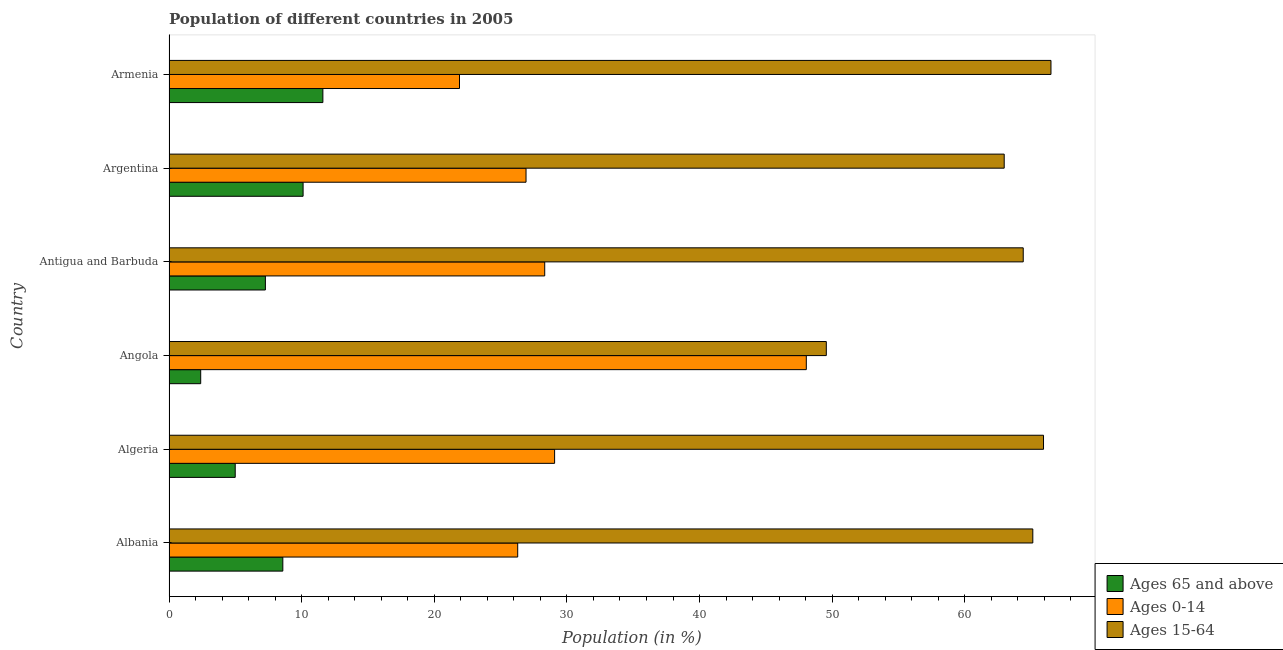How many different coloured bars are there?
Your answer should be compact. 3. How many bars are there on the 3rd tick from the top?
Ensure brevity in your answer.  3. How many bars are there on the 3rd tick from the bottom?
Offer a terse response. 3. In how many cases, is the number of bars for a given country not equal to the number of legend labels?
Provide a succinct answer. 0. What is the percentage of population within the age-group 0-14 in Armenia?
Your answer should be very brief. 21.9. Across all countries, what is the maximum percentage of population within the age-group of 65 and above?
Keep it short and to the point. 11.6. Across all countries, what is the minimum percentage of population within the age-group 0-14?
Keep it short and to the point. 21.9. In which country was the percentage of population within the age-group of 65 and above maximum?
Your response must be concise. Armenia. In which country was the percentage of population within the age-group 15-64 minimum?
Offer a terse response. Angola. What is the total percentage of population within the age-group 15-64 in the graph?
Offer a terse response. 374.49. What is the difference between the percentage of population within the age-group 15-64 in Albania and that in Algeria?
Provide a short and direct response. -0.81. What is the difference between the percentage of population within the age-group 0-14 in Argentina and the percentage of population within the age-group 15-64 in Armenia?
Provide a succinct answer. -39.58. What is the average percentage of population within the age-group 15-64 per country?
Offer a terse response. 62.41. What is the difference between the percentage of population within the age-group 0-14 and percentage of population within the age-group of 65 and above in Angola?
Make the answer very short. 45.66. What is the ratio of the percentage of population within the age-group of 65 and above in Albania to that in Armenia?
Offer a terse response. 0.74. What is the difference between the highest and the second highest percentage of population within the age-group 0-14?
Offer a very short reply. 18.98. What is the difference between the highest and the lowest percentage of population within the age-group 15-64?
Ensure brevity in your answer.  16.94. What does the 3rd bar from the top in Albania represents?
Make the answer very short. Ages 65 and above. What does the 1st bar from the bottom in Armenia represents?
Keep it short and to the point. Ages 65 and above. Is it the case that in every country, the sum of the percentage of population within the age-group of 65 and above and percentage of population within the age-group 0-14 is greater than the percentage of population within the age-group 15-64?
Make the answer very short. No. Are all the bars in the graph horizontal?
Offer a terse response. Yes. How many countries are there in the graph?
Give a very brief answer. 6. What is the difference between two consecutive major ticks on the X-axis?
Offer a terse response. 10. Are the values on the major ticks of X-axis written in scientific E-notation?
Ensure brevity in your answer.  No. How many legend labels are there?
Your response must be concise. 3. How are the legend labels stacked?
Your response must be concise. Vertical. What is the title of the graph?
Ensure brevity in your answer.  Population of different countries in 2005. What is the label or title of the X-axis?
Give a very brief answer. Population (in %). What is the Population (in %) of Ages 65 and above in Albania?
Your answer should be very brief. 8.58. What is the Population (in %) of Ages 0-14 in Albania?
Offer a terse response. 26.29. What is the Population (in %) of Ages 15-64 in Albania?
Keep it short and to the point. 65.13. What is the Population (in %) in Ages 65 and above in Algeria?
Keep it short and to the point. 4.99. What is the Population (in %) of Ages 0-14 in Algeria?
Provide a short and direct response. 29.07. What is the Population (in %) in Ages 15-64 in Algeria?
Offer a very short reply. 65.93. What is the Population (in %) of Ages 65 and above in Angola?
Your response must be concise. 2.39. What is the Population (in %) of Ages 0-14 in Angola?
Provide a succinct answer. 48.05. What is the Population (in %) in Ages 15-64 in Angola?
Your response must be concise. 49.56. What is the Population (in %) of Ages 65 and above in Antigua and Barbuda?
Make the answer very short. 7.27. What is the Population (in %) in Ages 0-14 in Antigua and Barbuda?
Keep it short and to the point. 28.33. What is the Population (in %) of Ages 15-64 in Antigua and Barbuda?
Offer a terse response. 64.41. What is the Population (in %) in Ages 65 and above in Argentina?
Your answer should be very brief. 10.11. What is the Population (in %) of Ages 0-14 in Argentina?
Provide a succinct answer. 26.92. What is the Population (in %) of Ages 15-64 in Argentina?
Offer a terse response. 62.97. What is the Population (in %) in Ages 65 and above in Armenia?
Your answer should be compact. 11.6. What is the Population (in %) in Ages 0-14 in Armenia?
Make the answer very short. 21.9. What is the Population (in %) of Ages 15-64 in Armenia?
Give a very brief answer. 66.5. Across all countries, what is the maximum Population (in %) in Ages 65 and above?
Offer a very short reply. 11.6. Across all countries, what is the maximum Population (in %) of Ages 0-14?
Make the answer very short. 48.05. Across all countries, what is the maximum Population (in %) of Ages 15-64?
Offer a very short reply. 66.5. Across all countries, what is the minimum Population (in %) in Ages 65 and above?
Offer a terse response. 2.39. Across all countries, what is the minimum Population (in %) in Ages 0-14?
Provide a short and direct response. 21.9. Across all countries, what is the minimum Population (in %) in Ages 15-64?
Your response must be concise. 49.56. What is the total Population (in %) of Ages 65 and above in the graph?
Your answer should be compact. 44.94. What is the total Population (in %) in Ages 0-14 in the graph?
Keep it short and to the point. 180.56. What is the total Population (in %) in Ages 15-64 in the graph?
Your response must be concise. 374.49. What is the difference between the Population (in %) of Ages 65 and above in Albania and that in Algeria?
Provide a succinct answer. 3.59. What is the difference between the Population (in %) in Ages 0-14 in Albania and that in Algeria?
Provide a short and direct response. -2.78. What is the difference between the Population (in %) of Ages 15-64 in Albania and that in Algeria?
Offer a very short reply. -0.81. What is the difference between the Population (in %) in Ages 65 and above in Albania and that in Angola?
Offer a terse response. 6.19. What is the difference between the Population (in %) of Ages 0-14 in Albania and that in Angola?
Your answer should be compact. -21.76. What is the difference between the Population (in %) of Ages 15-64 in Albania and that in Angola?
Offer a very short reply. 15.57. What is the difference between the Population (in %) of Ages 65 and above in Albania and that in Antigua and Barbuda?
Offer a terse response. 1.32. What is the difference between the Population (in %) in Ages 0-14 in Albania and that in Antigua and Barbuda?
Provide a short and direct response. -2.04. What is the difference between the Population (in %) of Ages 15-64 in Albania and that in Antigua and Barbuda?
Your answer should be compact. 0.72. What is the difference between the Population (in %) of Ages 65 and above in Albania and that in Argentina?
Your answer should be compact. -1.53. What is the difference between the Population (in %) in Ages 0-14 in Albania and that in Argentina?
Ensure brevity in your answer.  -0.63. What is the difference between the Population (in %) in Ages 15-64 in Albania and that in Argentina?
Keep it short and to the point. 2.16. What is the difference between the Population (in %) of Ages 65 and above in Albania and that in Armenia?
Your response must be concise. -3.02. What is the difference between the Population (in %) in Ages 0-14 in Albania and that in Armenia?
Your answer should be very brief. 4.39. What is the difference between the Population (in %) of Ages 15-64 in Albania and that in Armenia?
Your response must be concise. -1.37. What is the difference between the Population (in %) in Ages 65 and above in Algeria and that in Angola?
Your response must be concise. 2.6. What is the difference between the Population (in %) of Ages 0-14 in Algeria and that in Angola?
Offer a terse response. -18.98. What is the difference between the Population (in %) in Ages 15-64 in Algeria and that in Angola?
Offer a terse response. 16.38. What is the difference between the Population (in %) of Ages 65 and above in Algeria and that in Antigua and Barbuda?
Make the answer very short. -2.27. What is the difference between the Population (in %) in Ages 0-14 in Algeria and that in Antigua and Barbuda?
Make the answer very short. 0.75. What is the difference between the Population (in %) of Ages 15-64 in Algeria and that in Antigua and Barbuda?
Your answer should be very brief. 1.53. What is the difference between the Population (in %) of Ages 65 and above in Algeria and that in Argentina?
Provide a short and direct response. -5.12. What is the difference between the Population (in %) of Ages 0-14 in Algeria and that in Argentina?
Make the answer very short. 2.15. What is the difference between the Population (in %) in Ages 15-64 in Algeria and that in Argentina?
Offer a terse response. 2.96. What is the difference between the Population (in %) in Ages 65 and above in Algeria and that in Armenia?
Ensure brevity in your answer.  -6.61. What is the difference between the Population (in %) of Ages 0-14 in Algeria and that in Armenia?
Make the answer very short. 7.17. What is the difference between the Population (in %) of Ages 15-64 in Algeria and that in Armenia?
Your response must be concise. -0.56. What is the difference between the Population (in %) in Ages 65 and above in Angola and that in Antigua and Barbuda?
Your answer should be compact. -4.88. What is the difference between the Population (in %) of Ages 0-14 in Angola and that in Antigua and Barbuda?
Offer a terse response. 19.72. What is the difference between the Population (in %) in Ages 15-64 in Angola and that in Antigua and Barbuda?
Your answer should be very brief. -14.85. What is the difference between the Population (in %) in Ages 65 and above in Angola and that in Argentina?
Your answer should be compact. -7.72. What is the difference between the Population (in %) in Ages 0-14 in Angola and that in Argentina?
Make the answer very short. 21.13. What is the difference between the Population (in %) of Ages 15-64 in Angola and that in Argentina?
Your answer should be very brief. -13.41. What is the difference between the Population (in %) in Ages 65 and above in Angola and that in Armenia?
Your response must be concise. -9.21. What is the difference between the Population (in %) of Ages 0-14 in Angola and that in Armenia?
Your response must be concise. 26.15. What is the difference between the Population (in %) of Ages 15-64 in Angola and that in Armenia?
Provide a succinct answer. -16.94. What is the difference between the Population (in %) in Ages 65 and above in Antigua and Barbuda and that in Argentina?
Provide a succinct answer. -2.84. What is the difference between the Population (in %) of Ages 0-14 in Antigua and Barbuda and that in Argentina?
Offer a terse response. 1.41. What is the difference between the Population (in %) in Ages 15-64 in Antigua and Barbuda and that in Argentina?
Offer a very short reply. 1.43. What is the difference between the Population (in %) of Ages 65 and above in Antigua and Barbuda and that in Armenia?
Your answer should be compact. -4.33. What is the difference between the Population (in %) of Ages 0-14 in Antigua and Barbuda and that in Armenia?
Your answer should be compact. 6.43. What is the difference between the Population (in %) in Ages 15-64 in Antigua and Barbuda and that in Armenia?
Give a very brief answer. -2.09. What is the difference between the Population (in %) of Ages 65 and above in Argentina and that in Armenia?
Your answer should be compact. -1.49. What is the difference between the Population (in %) of Ages 0-14 in Argentina and that in Armenia?
Give a very brief answer. 5.02. What is the difference between the Population (in %) in Ages 15-64 in Argentina and that in Armenia?
Offer a very short reply. -3.53. What is the difference between the Population (in %) in Ages 65 and above in Albania and the Population (in %) in Ages 0-14 in Algeria?
Your answer should be very brief. -20.49. What is the difference between the Population (in %) in Ages 65 and above in Albania and the Population (in %) in Ages 15-64 in Algeria?
Offer a terse response. -57.35. What is the difference between the Population (in %) in Ages 0-14 in Albania and the Population (in %) in Ages 15-64 in Algeria?
Give a very brief answer. -39.64. What is the difference between the Population (in %) of Ages 65 and above in Albania and the Population (in %) of Ages 0-14 in Angola?
Offer a very short reply. -39.47. What is the difference between the Population (in %) of Ages 65 and above in Albania and the Population (in %) of Ages 15-64 in Angola?
Give a very brief answer. -40.98. What is the difference between the Population (in %) in Ages 0-14 in Albania and the Population (in %) in Ages 15-64 in Angola?
Offer a terse response. -23.27. What is the difference between the Population (in %) in Ages 65 and above in Albania and the Population (in %) in Ages 0-14 in Antigua and Barbuda?
Your answer should be compact. -19.75. What is the difference between the Population (in %) of Ages 65 and above in Albania and the Population (in %) of Ages 15-64 in Antigua and Barbuda?
Your answer should be very brief. -55.82. What is the difference between the Population (in %) in Ages 0-14 in Albania and the Population (in %) in Ages 15-64 in Antigua and Barbuda?
Provide a succinct answer. -38.11. What is the difference between the Population (in %) of Ages 65 and above in Albania and the Population (in %) of Ages 0-14 in Argentina?
Make the answer very short. -18.34. What is the difference between the Population (in %) of Ages 65 and above in Albania and the Population (in %) of Ages 15-64 in Argentina?
Provide a succinct answer. -54.39. What is the difference between the Population (in %) in Ages 0-14 in Albania and the Population (in %) in Ages 15-64 in Argentina?
Make the answer very short. -36.68. What is the difference between the Population (in %) of Ages 65 and above in Albania and the Population (in %) of Ages 0-14 in Armenia?
Keep it short and to the point. -13.32. What is the difference between the Population (in %) of Ages 65 and above in Albania and the Population (in %) of Ages 15-64 in Armenia?
Your answer should be very brief. -57.91. What is the difference between the Population (in %) of Ages 0-14 in Albania and the Population (in %) of Ages 15-64 in Armenia?
Offer a very short reply. -40.21. What is the difference between the Population (in %) in Ages 65 and above in Algeria and the Population (in %) in Ages 0-14 in Angola?
Your answer should be very brief. -43.06. What is the difference between the Population (in %) of Ages 65 and above in Algeria and the Population (in %) of Ages 15-64 in Angola?
Give a very brief answer. -44.57. What is the difference between the Population (in %) in Ages 0-14 in Algeria and the Population (in %) in Ages 15-64 in Angola?
Your answer should be compact. -20.49. What is the difference between the Population (in %) in Ages 65 and above in Algeria and the Population (in %) in Ages 0-14 in Antigua and Barbuda?
Ensure brevity in your answer.  -23.34. What is the difference between the Population (in %) in Ages 65 and above in Algeria and the Population (in %) in Ages 15-64 in Antigua and Barbuda?
Provide a short and direct response. -59.41. What is the difference between the Population (in %) in Ages 0-14 in Algeria and the Population (in %) in Ages 15-64 in Antigua and Barbuda?
Make the answer very short. -35.33. What is the difference between the Population (in %) in Ages 65 and above in Algeria and the Population (in %) in Ages 0-14 in Argentina?
Keep it short and to the point. -21.93. What is the difference between the Population (in %) of Ages 65 and above in Algeria and the Population (in %) of Ages 15-64 in Argentina?
Your answer should be very brief. -57.98. What is the difference between the Population (in %) of Ages 0-14 in Algeria and the Population (in %) of Ages 15-64 in Argentina?
Keep it short and to the point. -33.9. What is the difference between the Population (in %) of Ages 65 and above in Algeria and the Population (in %) of Ages 0-14 in Armenia?
Your answer should be very brief. -16.91. What is the difference between the Population (in %) of Ages 65 and above in Algeria and the Population (in %) of Ages 15-64 in Armenia?
Your response must be concise. -61.5. What is the difference between the Population (in %) of Ages 0-14 in Algeria and the Population (in %) of Ages 15-64 in Armenia?
Make the answer very short. -37.42. What is the difference between the Population (in %) in Ages 65 and above in Angola and the Population (in %) in Ages 0-14 in Antigua and Barbuda?
Provide a short and direct response. -25.94. What is the difference between the Population (in %) in Ages 65 and above in Angola and the Population (in %) in Ages 15-64 in Antigua and Barbuda?
Keep it short and to the point. -62.01. What is the difference between the Population (in %) in Ages 0-14 in Angola and the Population (in %) in Ages 15-64 in Antigua and Barbuda?
Provide a short and direct response. -16.35. What is the difference between the Population (in %) of Ages 65 and above in Angola and the Population (in %) of Ages 0-14 in Argentina?
Give a very brief answer. -24.53. What is the difference between the Population (in %) of Ages 65 and above in Angola and the Population (in %) of Ages 15-64 in Argentina?
Provide a short and direct response. -60.58. What is the difference between the Population (in %) in Ages 0-14 in Angola and the Population (in %) in Ages 15-64 in Argentina?
Your answer should be very brief. -14.92. What is the difference between the Population (in %) in Ages 65 and above in Angola and the Population (in %) in Ages 0-14 in Armenia?
Provide a short and direct response. -19.51. What is the difference between the Population (in %) in Ages 65 and above in Angola and the Population (in %) in Ages 15-64 in Armenia?
Make the answer very short. -64.11. What is the difference between the Population (in %) in Ages 0-14 in Angola and the Population (in %) in Ages 15-64 in Armenia?
Your answer should be very brief. -18.45. What is the difference between the Population (in %) of Ages 65 and above in Antigua and Barbuda and the Population (in %) of Ages 0-14 in Argentina?
Offer a terse response. -19.65. What is the difference between the Population (in %) of Ages 65 and above in Antigua and Barbuda and the Population (in %) of Ages 15-64 in Argentina?
Give a very brief answer. -55.7. What is the difference between the Population (in %) in Ages 0-14 in Antigua and Barbuda and the Population (in %) in Ages 15-64 in Argentina?
Your response must be concise. -34.64. What is the difference between the Population (in %) in Ages 65 and above in Antigua and Barbuda and the Population (in %) in Ages 0-14 in Armenia?
Provide a succinct answer. -14.64. What is the difference between the Population (in %) in Ages 65 and above in Antigua and Barbuda and the Population (in %) in Ages 15-64 in Armenia?
Offer a very short reply. -59.23. What is the difference between the Population (in %) of Ages 0-14 in Antigua and Barbuda and the Population (in %) of Ages 15-64 in Armenia?
Make the answer very short. -38.17. What is the difference between the Population (in %) of Ages 65 and above in Argentina and the Population (in %) of Ages 0-14 in Armenia?
Give a very brief answer. -11.79. What is the difference between the Population (in %) of Ages 65 and above in Argentina and the Population (in %) of Ages 15-64 in Armenia?
Ensure brevity in your answer.  -56.39. What is the difference between the Population (in %) in Ages 0-14 in Argentina and the Population (in %) in Ages 15-64 in Armenia?
Make the answer very short. -39.58. What is the average Population (in %) of Ages 65 and above per country?
Your response must be concise. 7.49. What is the average Population (in %) of Ages 0-14 per country?
Give a very brief answer. 30.09. What is the average Population (in %) in Ages 15-64 per country?
Provide a succinct answer. 62.42. What is the difference between the Population (in %) in Ages 65 and above and Population (in %) in Ages 0-14 in Albania?
Offer a terse response. -17.71. What is the difference between the Population (in %) in Ages 65 and above and Population (in %) in Ages 15-64 in Albania?
Your answer should be very brief. -56.54. What is the difference between the Population (in %) in Ages 0-14 and Population (in %) in Ages 15-64 in Albania?
Provide a short and direct response. -38.84. What is the difference between the Population (in %) of Ages 65 and above and Population (in %) of Ages 0-14 in Algeria?
Ensure brevity in your answer.  -24.08. What is the difference between the Population (in %) of Ages 65 and above and Population (in %) of Ages 15-64 in Algeria?
Provide a succinct answer. -60.94. What is the difference between the Population (in %) in Ages 0-14 and Population (in %) in Ages 15-64 in Algeria?
Offer a very short reply. -36.86. What is the difference between the Population (in %) in Ages 65 and above and Population (in %) in Ages 0-14 in Angola?
Provide a succinct answer. -45.66. What is the difference between the Population (in %) of Ages 65 and above and Population (in %) of Ages 15-64 in Angola?
Provide a succinct answer. -47.17. What is the difference between the Population (in %) of Ages 0-14 and Population (in %) of Ages 15-64 in Angola?
Make the answer very short. -1.51. What is the difference between the Population (in %) in Ages 65 and above and Population (in %) in Ages 0-14 in Antigua and Barbuda?
Your answer should be compact. -21.06. What is the difference between the Population (in %) of Ages 65 and above and Population (in %) of Ages 15-64 in Antigua and Barbuda?
Offer a terse response. -57.14. What is the difference between the Population (in %) in Ages 0-14 and Population (in %) in Ages 15-64 in Antigua and Barbuda?
Provide a succinct answer. -36.08. What is the difference between the Population (in %) of Ages 65 and above and Population (in %) of Ages 0-14 in Argentina?
Provide a succinct answer. -16.81. What is the difference between the Population (in %) in Ages 65 and above and Population (in %) in Ages 15-64 in Argentina?
Make the answer very short. -52.86. What is the difference between the Population (in %) in Ages 0-14 and Population (in %) in Ages 15-64 in Argentina?
Offer a terse response. -36.05. What is the difference between the Population (in %) of Ages 65 and above and Population (in %) of Ages 0-14 in Armenia?
Make the answer very short. -10.3. What is the difference between the Population (in %) of Ages 65 and above and Population (in %) of Ages 15-64 in Armenia?
Offer a very short reply. -54.9. What is the difference between the Population (in %) of Ages 0-14 and Population (in %) of Ages 15-64 in Armenia?
Provide a short and direct response. -44.59. What is the ratio of the Population (in %) of Ages 65 and above in Albania to that in Algeria?
Provide a succinct answer. 1.72. What is the ratio of the Population (in %) of Ages 0-14 in Albania to that in Algeria?
Keep it short and to the point. 0.9. What is the ratio of the Population (in %) of Ages 65 and above in Albania to that in Angola?
Provide a succinct answer. 3.59. What is the ratio of the Population (in %) of Ages 0-14 in Albania to that in Angola?
Provide a short and direct response. 0.55. What is the ratio of the Population (in %) in Ages 15-64 in Albania to that in Angola?
Offer a very short reply. 1.31. What is the ratio of the Population (in %) in Ages 65 and above in Albania to that in Antigua and Barbuda?
Ensure brevity in your answer.  1.18. What is the ratio of the Population (in %) in Ages 0-14 in Albania to that in Antigua and Barbuda?
Your answer should be very brief. 0.93. What is the ratio of the Population (in %) in Ages 15-64 in Albania to that in Antigua and Barbuda?
Ensure brevity in your answer.  1.01. What is the ratio of the Population (in %) in Ages 65 and above in Albania to that in Argentina?
Your answer should be very brief. 0.85. What is the ratio of the Population (in %) in Ages 0-14 in Albania to that in Argentina?
Your answer should be very brief. 0.98. What is the ratio of the Population (in %) in Ages 15-64 in Albania to that in Argentina?
Offer a terse response. 1.03. What is the ratio of the Population (in %) of Ages 65 and above in Albania to that in Armenia?
Keep it short and to the point. 0.74. What is the ratio of the Population (in %) in Ages 0-14 in Albania to that in Armenia?
Your answer should be very brief. 1.2. What is the ratio of the Population (in %) in Ages 15-64 in Albania to that in Armenia?
Ensure brevity in your answer.  0.98. What is the ratio of the Population (in %) of Ages 65 and above in Algeria to that in Angola?
Offer a very short reply. 2.09. What is the ratio of the Population (in %) in Ages 0-14 in Algeria to that in Angola?
Make the answer very short. 0.61. What is the ratio of the Population (in %) in Ages 15-64 in Algeria to that in Angola?
Your answer should be compact. 1.33. What is the ratio of the Population (in %) in Ages 65 and above in Algeria to that in Antigua and Barbuda?
Offer a very short reply. 0.69. What is the ratio of the Population (in %) of Ages 0-14 in Algeria to that in Antigua and Barbuda?
Your answer should be compact. 1.03. What is the ratio of the Population (in %) of Ages 15-64 in Algeria to that in Antigua and Barbuda?
Make the answer very short. 1.02. What is the ratio of the Population (in %) in Ages 65 and above in Algeria to that in Argentina?
Your response must be concise. 0.49. What is the ratio of the Population (in %) of Ages 0-14 in Algeria to that in Argentina?
Provide a short and direct response. 1.08. What is the ratio of the Population (in %) in Ages 15-64 in Algeria to that in Argentina?
Ensure brevity in your answer.  1.05. What is the ratio of the Population (in %) in Ages 65 and above in Algeria to that in Armenia?
Your answer should be very brief. 0.43. What is the ratio of the Population (in %) in Ages 0-14 in Algeria to that in Armenia?
Your answer should be compact. 1.33. What is the ratio of the Population (in %) in Ages 15-64 in Algeria to that in Armenia?
Give a very brief answer. 0.99. What is the ratio of the Population (in %) in Ages 65 and above in Angola to that in Antigua and Barbuda?
Your answer should be very brief. 0.33. What is the ratio of the Population (in %) of Ages 0-14 in Angola to that in Antigua and Barbuda?
Give a very brief answer. 1.7. What is the ratio of the Population (in %) in Ages 15-64 in Angola to that in Antigua and Barbuda?
Provide a succinct answer. 0.77. What is the ratio of the Population (in %) in Ages 65 and above in Angola to that in Argentina?
Give a very brief answer. 0.24. What is the ratio of the Population (in %) in Ages 0-14 in Angola to that in Argentina?
Your response must be concise. 1.78. What is the ratio of the Population (in %) of Ages 15-64 in Angola to that in Argentina?
Keep it short and to the point. 0.79. What is the ratio of the Population (in %) of Ages 65 and above in Angola to that in Armenia?
Ensure brevity in your answer.  0.21. What is the ratio of the Population (in %) of Ages 0-14 in Angola to that in Armenia?
Offer a very short reply. 2.19. What is the ratio of the Population (in %) of Ages 15-64 in Angola to that in Armenia?
Offer a terse response. 0.75. What is the ratio of the Population (in %) in Ages 65 and above in Antigua and Barbuda to that in Argentina?
Ensure brevity in your answer.  0.72. What is the ratio of the Population (in %) of Ages 0-14 in Antigua and Barbuda to that in Argentina?
Your response must be concise. 1.05. What is the ratio of the Population (in %) of Ages 15-64 in Antigua and Barbuda to that in Argentina?
Your answer should be compact. 1.02. What is the ratio of the Population (in %) in Ages 65 and above in Antigua and Barbuda to that in Armenia?
Make the answer very short. 0.63. What is the ratio of the Population (in %) in Ages 0-14 in Antigua and Barbuda to that in Armenia?
Your answer should be very brief. 1.29. What is the ratio of the Population (in %) of Ages 15-64 in Antigua and Barbuda to that in Armenia?
Provide a short and direct response. 0.97. What is the ratio of the Population (in %) of Ages 65 and above in Argentina to that in Armenia?
Ensure brevity in your answer.  0.87. What is the ratio of the Population (in %) of Ages 0-14 in Argentina to that in Armenia?
Make the answer very short. 1.23. What is the ratio of the Population (in %) in Ages 15-64 in Argentina to that in Armenia?
Your answer should be compact. 0.95. What is the difference between the highest and the second highest Population (in %) of Ages 65 and above?
Offer a terse response. 1.49. What is the difference between the highest and the second highest Population (in %) in Ages 0-14?
Your answer should be very brief. 18.98. What is the difference between the highest and the second highest Population (in %) of Ages 15-64?
Keep it short and to the point. 0.56. What is the difference between the highest and the lowest Population (in %) of Ages 65 and above?
Keep it short and to the point. 9.21. What is the difference between the highest and the lowest Population (in %) in Ages 0-14?
Provide a succinct answer. 26.15. What is the difference between the highest and the lowest Population (in %) of Ages 15-64?
Your answer should be very brief. 16.94. 